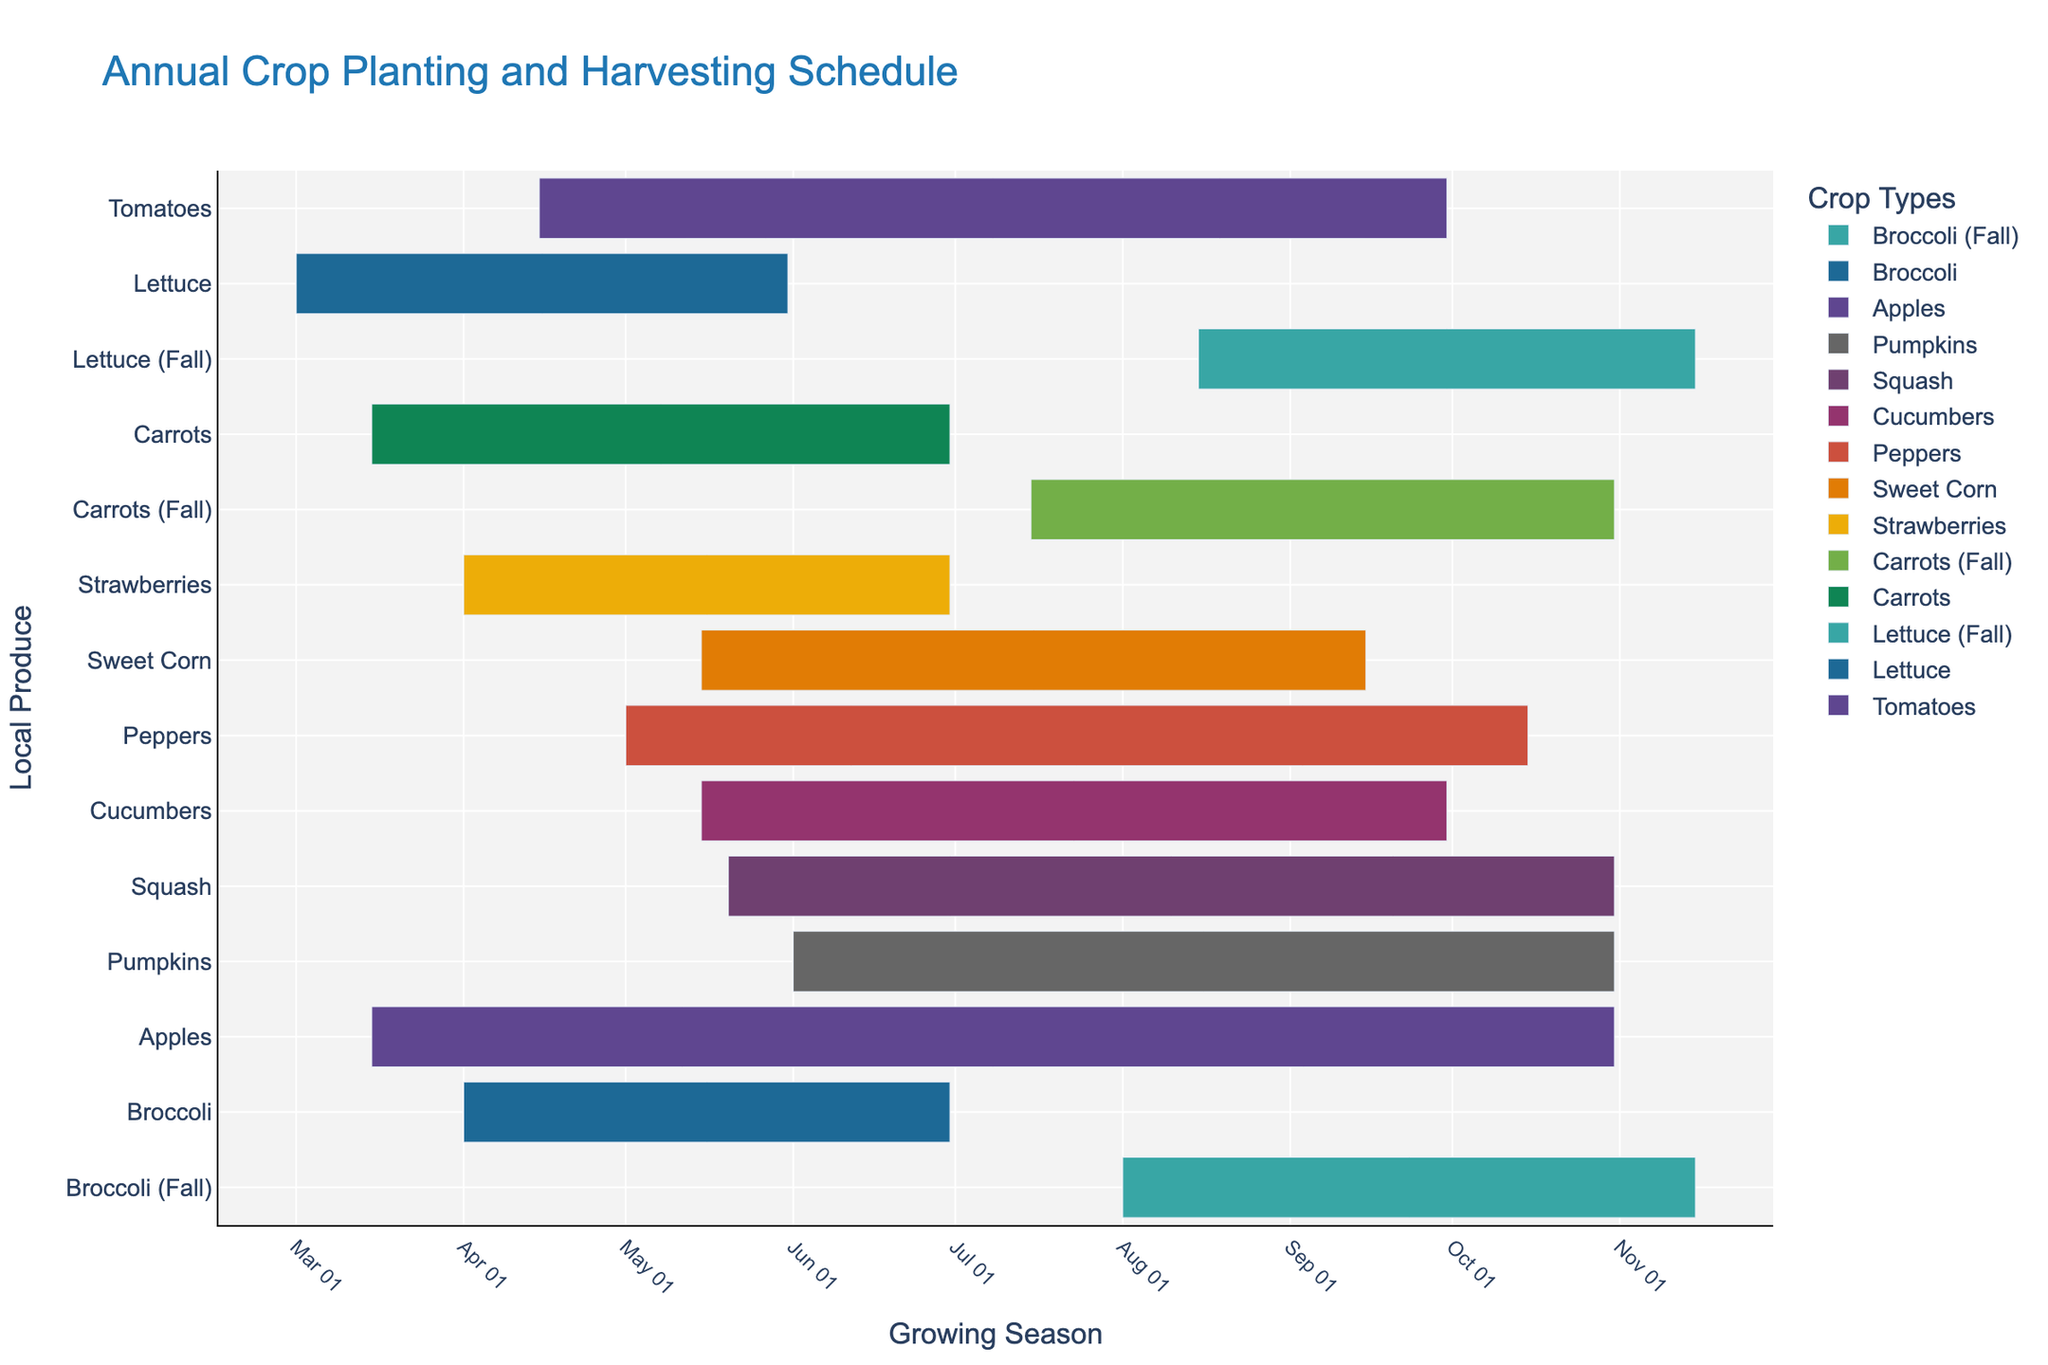What is the title of the figure? The title is usually displayed prominently at the top of the Gantt chart. It provides an immediate understanding of what the figure is about.
Answer: Annual Crop Planting and Harvesting Schedule Which crop has the shortest growing season? Compare the start and end dates for each crop and identify the one with the least amount of time between these dates.
Answer: Lettuce (Spring) How many crops are shown in the figure? Count the number of unique crop entries in the figure. Each unique crop corresponds to one data point.
Answer: 14 What is the total duration for both growing seasons of Carrots? Calculate the duration for each Carrots growing season by subtracting start dates from end dates, then sum these durations.
Answer: (June 30 - March 15 = 107 days) + (October 31 - July 15 = 108 days) = 215 days What is the average planting date for all crops? Convert all planting dates to numerical values, sum them up, and divide by the total number of crops. Then convert back to a date.
Answer: April 21 Which crop has a longer growing season, Tomatoes or Sweet Corn? Compare the start and end dates of Tomatoes and Sweet Corn to determine which spans a longer duration.
Answer: Tomatoes Which crop starts later, Pumpkins or Squash? Compare the start dates of Pumpkins and Squash to determine which one begins planting later in the year.
Answer: Squash Which crops have overlapping growing seasons in September? Identify the crops that have both start and end dates spanning the month of September.
Answer: Tomatoes, Sweet Corn, Peppers, Cucumbers, Squash, Pumpkins, Apples When is the peak planting time with the most crops being planted? Determine which specific date or range of dates has the highest concentration of start dates.
Answer: Mid-May Which fall crops have overlapping growing seasons in October? Identify all crops classified as fall crops and see which ones have a growing season that overlaps in October.
Answer: Lettuce (Fall), Carrots (Fall), Broccoli (Fall), Squash, Pumpkins, Apple 